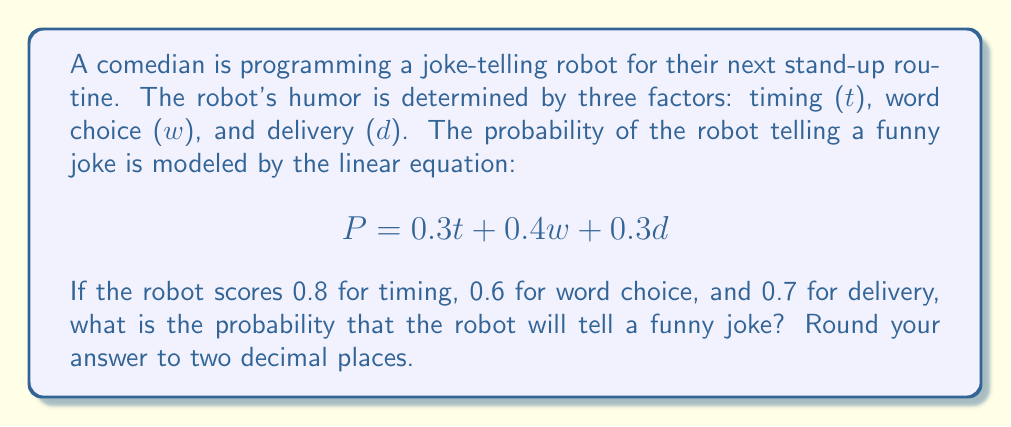Solve this math problem. To solve this problem, we'll follow these steps:

1) We're given the linear equation for the probability of a funny joke:
   $P = 0.3t + 0.4w + 0.3d$

2) We're also given the scores for each factor:
   Timing (t) = 0.8
   Word choice (w) = 0.6
   Delivery (d) = 0.7

3) Let's substitute these values into our equation:
   $P = 0.3(0.8) + 0.4(0.6) + 0.3(0.7)$

4) Now, let's calculate each term:
   $0.3(0.8) = 0.24$
   $0.4(0.6) = 0.24$
   $0.3(0.7) = 0.21$

5) Sum up all the terms:
   $P = 0.24 + 0.24 + 0.21 = 0.69$

6) Rounding to two decimal places:
   $P ≈ 0.69$

Therefore, the probability that the robot will tell a funny joke is 0.69 or 69%.
Answer: 0.69 